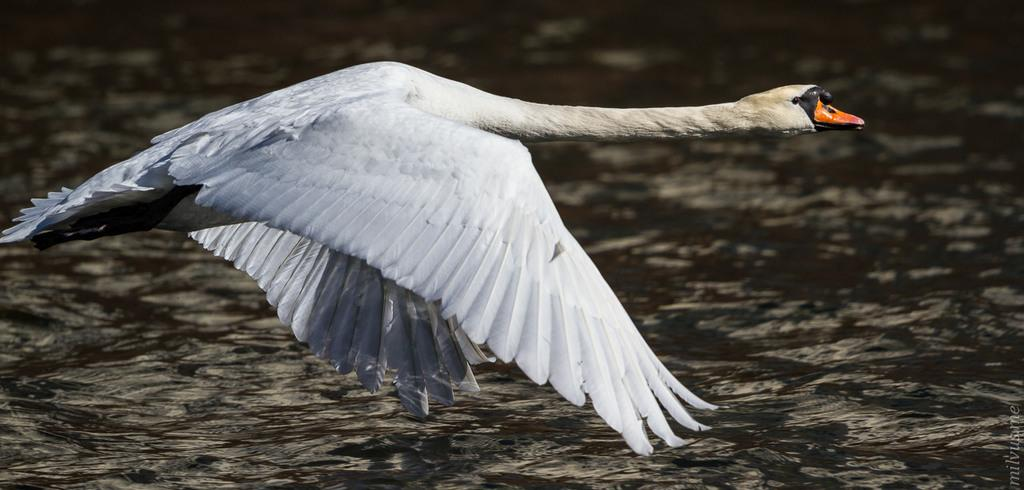What animal is present in the image? There is a swan in the image. What is the swan doing in the image? The swan is flying on the water in the image. What color is the swan? The swan is white in color. What color is the swan's beak? The swan's beak is orange. What type of error message can be seen on the swan's wing in the image? There is no error message present on the swan's wing in the image. What kind of mist is visible around the swan in the image? There is no mist visible around the swan in the image. 